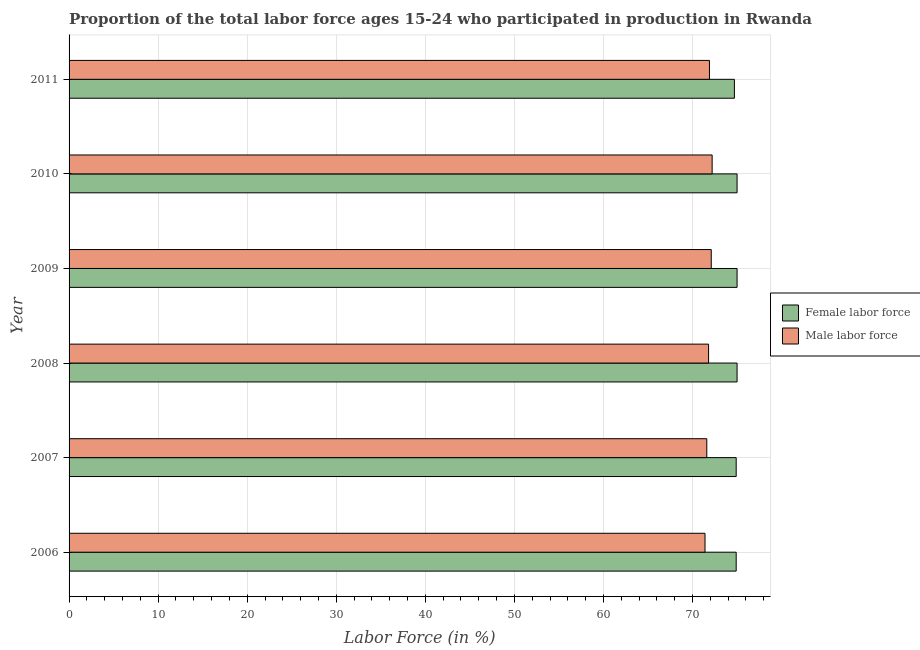How many groups of bars are there?
Provide a succinct answer. 6. How many bars are there on the 1st tick from the top?
Provide a short and direct response. 2. How many bars are there on the 1st tick from the bottom?
Your answer should be very brief. 2. In how many cases, is the number of bars for a given year not equal to the number of legend labels?
Ensure brevity in your answer.  0. What is the percentage of female labor force in 2007?
Provide a short and direct response. 74.9. Across all years, what is the maximum percentage of male labour force?
Your answer should be compact. 72.2. Across all years, what is the minimum percentage of female labor force?
Your answer should be compact. 74.7. What is the total percentage of female labor force in the graph?
Offer a very short reply. 449.5. What is the difference between the percentage of male labour force in 2008 and the percentage of female labor force in 2010?
Your response must be concise. -3.2. What is the average percentage of male labour force per year?
Your response must be concise. 71.83. In how many years, is the percentage of male labour force greater than 52 %?
Provide a short and direct response. 6. What is the ratio of the percentage of male labour force in 2009 to that in 2011?
Offer a terse response. 1. Is the percentage of male labour force in 2007 less than that in 2010?
Offer a very short reply. Yes. What is the difference between the highest and the second highest percentage of male labour force?
Keep it short and to the point. 0.1. Is the sum of the percentage of male labour force in 2010 and 2011 greater than the maximum percentage of female labor force across all years?
Offer a terse response. Yes. What does the 2nd bar from the top in 2008 represents?
Provide a short and direct response. Female labor force. What does the 1st bar from the bottom in 2009 represents?
Your response must be concise. Female labor force. How many years are there in the graph?
Ensure brevity in your answer.  6. What is the difference between two consecutive major ticks on the X-axis?
Provide a short and direct response. 10. Where does the legend appear in the graph?
Your answer should be very brief. Center right. How many legend labels are there?
Your response must be concise. 2. What is the title of the graph?
Keep it short and to the point. Proportion of the total labor force ages 15-24 who participated in production in Rwanda. What is the label or title of the X-axis?
Provide a short and direct response. Labor Force (in %). What is the Labor Force (in %) of Female labor force in 2006?
Give a very brief answer. 74.9. What is the Labor Force (in %) in Male labor force in 2006?
Keep it short and to the point. 71.4. What is the Labor Force (in %) in Female labor force in 2007?
Provide a succinct answer. 74.9. What is the Labor Force (in %) in Male labor force in 2007?
Ensure brevity in your answer.  71.6. What is the Labor Force (in %) in Female labor force in 2008?
Give a very brief answer. 75. What is the Labor Force (in %) in Male labor force in 2008?
Offer a very short reply. 71.8. What is the Labor Force (in %) in Male labor force in 2009?
Your answer should be very brief. 72.1. What is the Labor Force (in %) of Female labor force in 2010?
Offer a very short reply. 75. What is the Labor Force (in %) of Male labor force in 2010?
Make the answer very short. 72.2. What is the Labor Force (in %) in Female labor force in 2011?
Provide a succinct answer. 74.7. What is the Labor Force (in %) of Male labor force in 2011?
Make the answer very short. 71.9. Across all years, what is the maximum Labor Force (in %) in Female labor force?
Your response must be concise. 75. Across all years, what is the maximum Labor Force (in %) in Male labor force?
Give a very brief answer. 72.2. Across all years, what is the minimum Labor Force (in %) of Female labor force?
Offer a terse response. 74.7. Across all years, what is the minimum Labor Force (in %) in Male labor force?
Provide a succinct answer. 71.4. What is the total Labor Force (in %) of Female labor force in the graph?
Your answer should be compact. 449.5. What is the total Labor Force (in %) of Male labor force in the graph?
Your answer should be very brief. 431. What is the difference between the Labor Force (in %) of Female labor force in 2006 and that in 2007?
Offer a very short reply. 0. What is the difference between the Labor Force (in %) of Male labor force in 2006 and that in 2007?
Your answer should be compact. -0.2. What is the difference between the Labor Force (in %) of Male labor force in 2006 and that in 2008?
Give a very brief answer. -0.4. What is the difference between the Labor Force (in %) of Male labor force in 2006 and that in 2009?
Give a very brief answer. -0.7. What is the difference between the Labor Force (in %) of Male labor force in 2007 and that in 2010?
Make the answer very short. -0.6. What is the difference between the Labor Force (in %) of Female labor force in 2007 and that in 2011?
Make the answer very short. 0.2. What is the difference between the Labor Force (in %) in Female labor force in 2008 and that in 2009?
Make the answer very short. 0. What is the difference between the Labor Force (in %) in Male labor force in 2008 and that in 2009?
Your answer should be very brief. -0.3. What is the difference between the Labor Force (in %) of Male labor force in 2008 and that in 2010?
Provide a succinct answer. -0.4. What is the difference between the Labor Force (in %) in Female labor force in 2008 and that in 2011?
Provide a succinct answer. 0.3. What is the difference between the Labor Force (in %) of Male labor force in 2008 and that in 2011?
Ensure brevity in your answer.  -0.1. What is the difference between the Labor Force (in %) in Male labor force in 2010 and that in 2011?
Ensure brevity in your answer.  0.3. What is the difference between the Labor Force (in %) of Female labor force in 2006 and the Labor Force (in %) of Male labor force in 2007?
Your response must be concise. 3.3. What is the difference between the Labor Force (in %) of Female labor force in 2007 and the Labor Force (in %) of Male labor force in 2008?
Your answer should be very brief. 3.1. What is the difference between the Labor Force (in %) of Female labor force in 2007 and the Labor Force (in %) of Male labor force in 2011?
Keep it short and to the point. 3. What is the difference between the Labor Force (in %) of Female labor force in 2008 and the Labor Force (in %) of Male labor force in 2009?
Provide a succinct answer. 2.9. What is the difference between the Labor Force (in %) of Female labor force in 2008 and the Labor Force (in %) of Male labor force in 2010?
Make the answer very short. 2.8. What is the difference between the Labor Force (in %) of Female labor force in 2008 and the Labor Force (in %) of Male labor force in 2011?
Ensure brevity in your answer.  3.1. What is the difference between the Labor Force (in %) in Female labor force in 2009 and the Labor Force (in %) in Male labor force in 2010?
Your answer should be compact. 2.8. What is the difference between the Labor Force (in %) of Female labor force in 2009 and the Labor Force (in %) of Male labor force in 2011?
Your response must be concise. 3.1. What is the difference between the Labor Force (in %) in Female labor force in 2010 and the Labor Force (in %) in Male labor force in 2011?
Your response must be concise. 3.1. What is the average Labor Force (in %) of Female labor force per year?
Your answer should be very brief. 74.92. What is the average Labor Force (in %) in Male labor force per year?
Your response must be concise. 71.83. In the year 2006, what is the difference between the Labor Force (in %) in Female labor force and Labor Force (in %) in Male labor force?
Give a very brief answer. 3.5. In the year 2009, what is the difference between the Labor Force (in %) in Female labor force and Labor Force (in %) in Male labor force?
Offer a terse response. 2.9. In the year 2011, what is the difference between the Labor Force (in %) of Female labor force and Labor Force (in %) of Male labor force?
Make the answer very short. 2.8. What is the ratio of the Labor Force (in %) in Male labor force in 2006 to that in 2007?
Make the answer very short. 1. What is the ratio of the Labor Force (in %) in Male labor force in 2006 to that in 2008?
Keep it short and to the point. 0.99. What is the ratio of the Labor Force (in %) in Female labor force in 2006 to that in 2009?
Your response must be concise. 1. What is the ratio of the Labor Force (in %) of Male labor force in 2006 to that in 2009?
Offer a very short reply. 0.99. What is the ratio of the Labor Force (in %) of Male labor force in 2006 to that in 2010?
Ensure brevity in your answer.  0.99. What is the ratio of the Labor Force (in %) in Female labor force in 2006 to that in 2011?
Your answer should be compact. 1. What is the ratio of the Labor Force (in %) in Male labor force in 2007 to that in 2008?
Your answer should be very brief. 1. What is the ratio of the Labor Force (in %) in Female labor force in 2007 to that in 2009?
Your answer should be compact. 1. What is the ratio of the Labor Force (in %) in Male labor force in 2007 to that in 2009?
Your response must be concise. 0.99. What is the ratio of the Labor Force (in %) of Female labor force in 2007 to that in 2010?
Keep it short and to the point. 1. What is the ratio of the Labor Force (in %) in Male labor force in 2007 to that in 2011?
Give a very brief answer. 1. What is the ratio of the Labor Force (in %) in Female labor force in 2008 to that in 2009?
Keep it short and to the point. 1. What is the ratio of the Labor Force (in %) of Male labor force in 2008 to that in 2009?
Your answer should be compact. 1. What is the ratio of the Labor Force (in %) in Male labor force in 2008 to that in 2010?
Offer a very short reply. 0.99. What is the ratio of the Labor Force (in %) in Male labor force in 2008 to that in 2011?
Provide a short and direct response. 1. What is the ratio of the Labor Force (in %) in Male labor force in 2009 to that in 2010?
Offer a terse response. 1. What is the ratio of the Labor Force (in %) of Female labor force in 2009 to that in 2011?
Keep it short and to the point. 1. What is the ratio of the Labor Force (in %) of Male labor force in 2010 to that in 2011?
Your response must be concise. 1. What is the difference between the highest and the second highest Labor Force (in %) of Male labor force?
Provide a succinct answer. 0.1. What is the difference between the highest and the lowest Labor Force (in %) of Female labor force?
Provide a succinct answer. 0.3. What is the difference between the highest and the lowest Labor Force (in %) of Male labor force?
Provide a short and direct response. 0.8. 